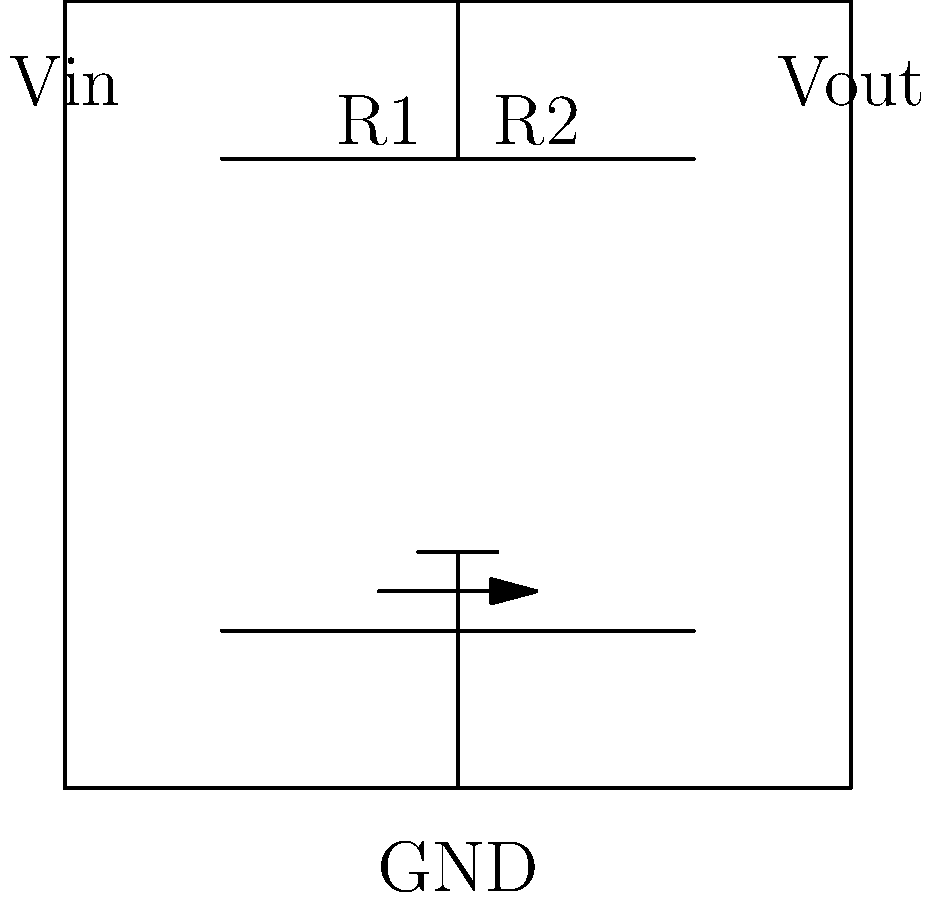In the variable voltage control circuit shown for a vaping device, what is the relationship between the output voltage (Vout) and the input voltage (Vin) in terms of the potentiometer's resistance values R1 and R2? To determine the relationship between Vout and Vin, we need to analyze the voltage divider circuit formed by the potentiometer:

1. The potentiometer acts as a variable voltage divider with total resistance R = R1 + R2.

2. The output voltage (Vout) is taken from the wiper of the potentiometer, which divides the resistance into R1 and R2.

3. In a voltage divider, the output voltage is proportional to the ratio of the resistance after the output point to the total resistance.

4. The voltage divider equation for this circuit is:

   $$V_{out} = V_{in} \cdot \frac{R2}{R1 + R2}$$

5. As the wiper moves, R1 and R2 change, but their sum remains constant.

6. When R2 increases (and R1 decreases), Vout increases, allowing for variable voltage control.

7. The range of Vout will be from 0V (when R2 = 0) to Vin (when R2 = R and R1 = 0).

This relationship allows the vaping enthusiast to adjust the output voltage by turning the potentiometer, thus controlling the power delivered to the heating element in the vaping device.
Answer: $$V_{out} = V_{in} \cdot \frac{R2}{R1 + R2}$$ 